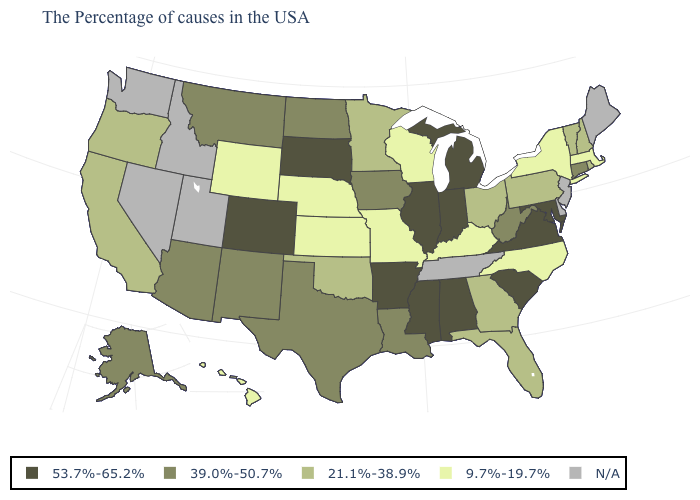Among the states that border Montana , does South Dakota have the highest value?
Concise answer only. Yes. Does the map have missing data?
Be succinct. Yes. Name the states that have a value in the range N/A?
Concise answer only. Maine, New Jersey, Delaware, Tennessee, Utah, Idaho, Nevada, Washington. What is the value of Delaware?
Concise answer only. N/A. Among the states that border Iowa , does Illinois have the highest value?
Short answer required. Yes. Which states have the lowest value in the Northeast?
Answer briefly. Massachusetts, New York. What is the value of Utah?
Concise answer only. N/A. Name the states that have a value in the range 39.0%-50.7%?
Give a very brief answer. Connecticut, West Virginia, Louisiana, Iowa, Texas, North Dakota, New Mexico, Montana, Arizona, Alaska. Among the states that border Kentucky , does Missouri have the lowest value?
Keep it brief. Yes. Does Texas have the highest value in the South?
Write a very short answer. No. Which states have the lowest value in the USA?
Short answer required. Massachusetts, New York, North Carolina, Kentucky, Wisconsin, Missouri, Kansas, Nebraska, Wyoming, Hawaii. Among the states that border South Dakota , does Montana have the highest value?
Concise answer only. Yes. What is the lowest value in the West?
Quick response, please. 9.7%-19.7%. What is the value of Connecticut?
Quick response, please. 39.0%-50.7%. What is the value of Minnesota?
Concise answer only. 21.1%-38.9%. 